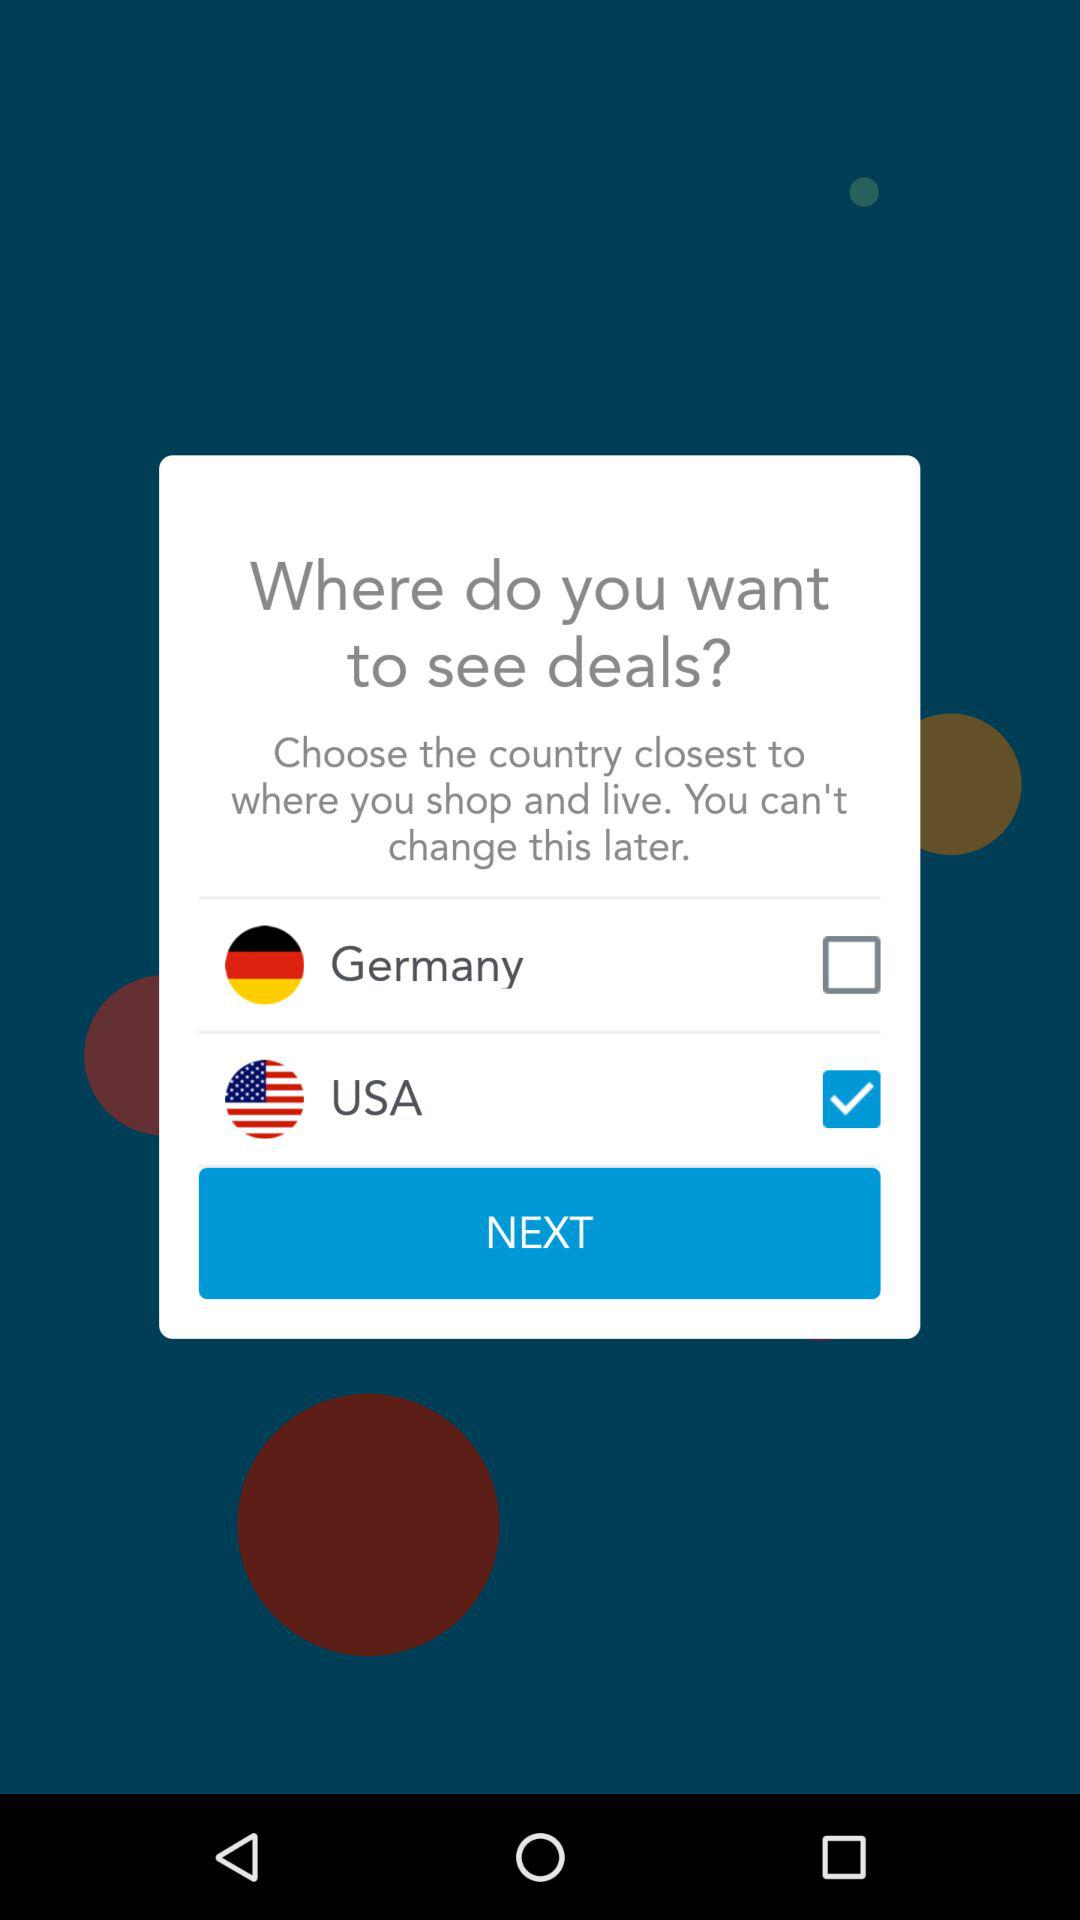Which country is selected? The selected country is the USA. 